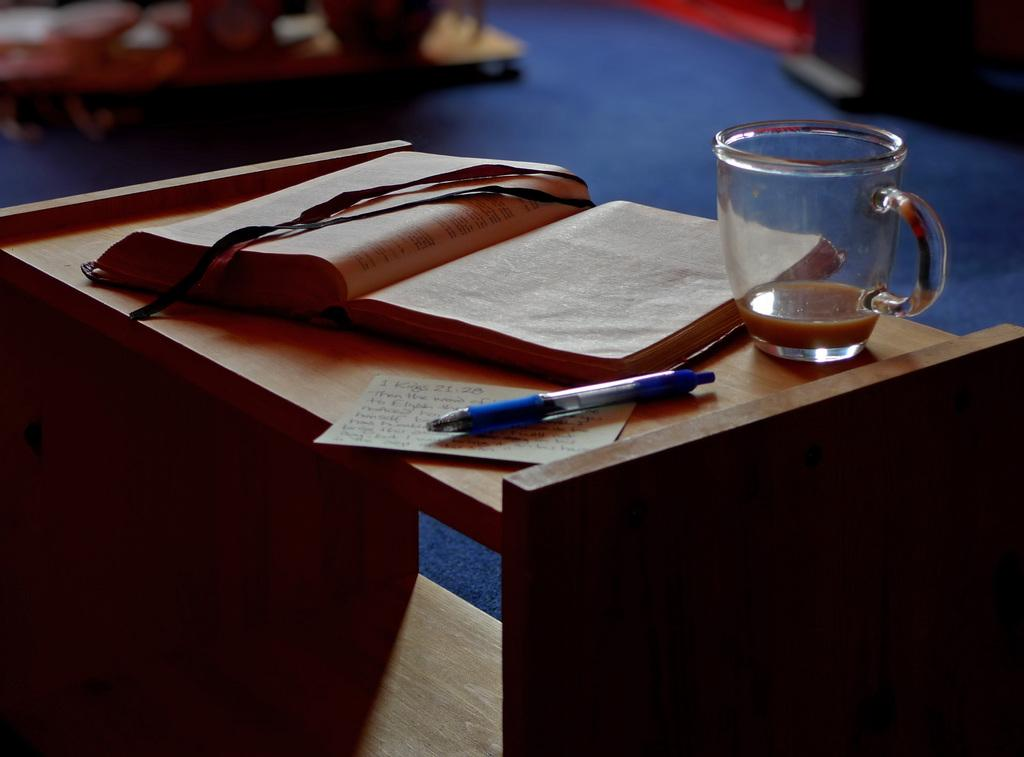What type of object can be seen in the image that is typically used for reading? There is a book in the image, which is typically used for reading. What object in the image might be used for holding a beverage? There is a cup in the image, which might be used for holding a beverage. What object in the image is commonly used for writing? There is a pen in the image, which is commonly used for writing. What material is the surface on which the objects are placed? The objects are placed on a wooden table. What type of furniture can be seen in the background of the image? There are wooden cabinets in the background of the image. What type of flooring is visible in the image? There is a blue-colored carpet in the image. What type of goat can be seen grazing on the blue-colored carpet in the image? There is no goat present in the image; it features a book, cup, pen, and paper on a wooden table with a blue-colored carpet. 